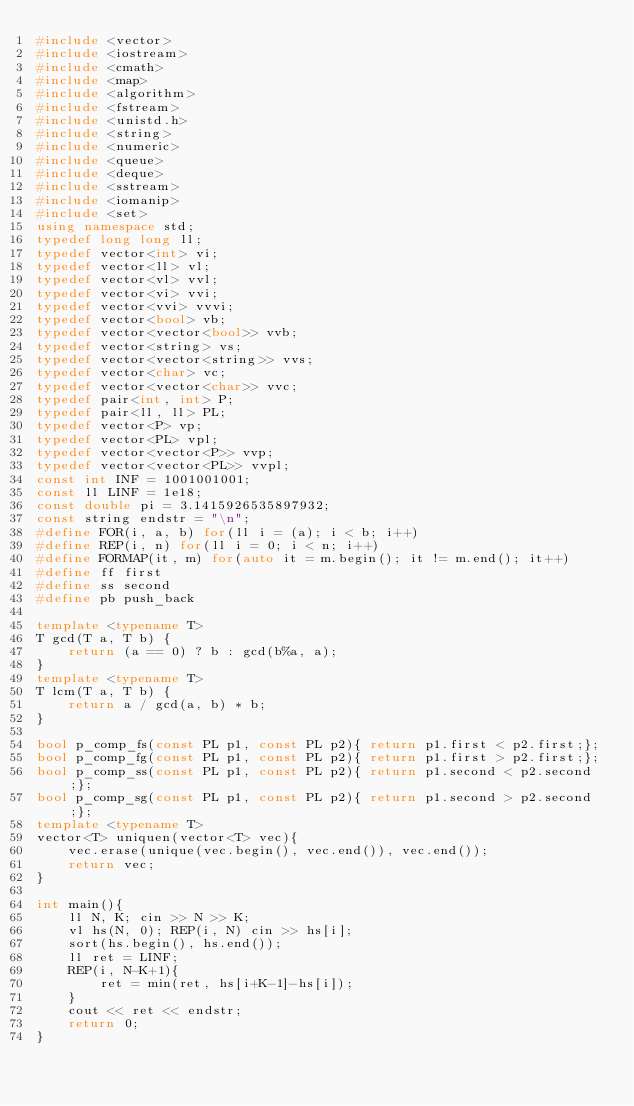<code> <loc_0><loc_0><loc_500><loc_500><_C++_>#include <vector>
#include <iostream>
#include <cmath>
#include <map>
#include <algorithm>
#include <fstream>
#include <unistd.h>
#include <string>
#include <numeric>
#include <queue>
#include <deque>
#include <sstream>
#include <iomanip>
#include <set>
using namespace std;
typedef long long ll;
typedef vector<int> vi;
typedef vector<ll> vl;
typedef vector<vl> vvl;
typedef vector<vi> vvi;
typedef vector<vvi> vvvi;
typedef vector<bool> vb;
typedef vector<vector<bool>> vvb;
typedef vector<string> vs;
typedef vector<vector<string>> vvs;
typedef vector<char> vc;
typedef vector<vector<char>> vvc;
typedef pair<int, int> P;
typedef pair<ll, ll> PL;
typedef vector<P> vp;
typedef vector<PL> vpl;
typedef vector<vector<P>> vvp;
typedef vector<vector<PL>> vvpl;
const int INF = 1001001001;
const ll LINF = 1e18;
const double pi = 3.1415926535897932;
const string endstr = "\n";
#define FOR(i, a, b) for(ll i = (a); i < b; i++)
#define REP(i, n) for(ll i = 0; i < n; i++)
#define FORMAP(it, m) for(auto it = m.begin(); it != m.end(); it++)
#define ff first
#define ss second
#define pb push_back

template <typename T>
T gcd(T a, T b) {
    return (a == 0) ? b : gcd(b%a, a);
}
template <typename T>
T lcm(T a, T b) {
    return a / gcd(a, b) * b;
}

bool p_comp_fs(const PL p1, const PL p2){ return p1.first < p2.first;};
bool p_comp_fg(const PL p1, const PL p2){ return p1.first > p2.first;};
bool p_comp_ss(const PL p1, const PL p2){ return p1.second < p2.second;};
bool p_comp_sg(const PL p1, const PL p2){ return p1.second > p2.second;};
template <typename T>
vector<T> uniquen(vector<T> vec){
    vec.erase(unique(vec.begin(), vec.end()), vec.end());
    return vec;
}

int main(){
    ll N, K; cin >> N >> K;
    vl hs(N, 0); REP(i, N) cin >> hs[i];
    sort(hs.begin(), hs.end());
    ll ret = LINF;
    REP(i, N-K+1){
        ret = min(ret, hs[i+K-1]-hs[i]);
    }
    cout << ret << endstr;
    return 0;
}
</code> 